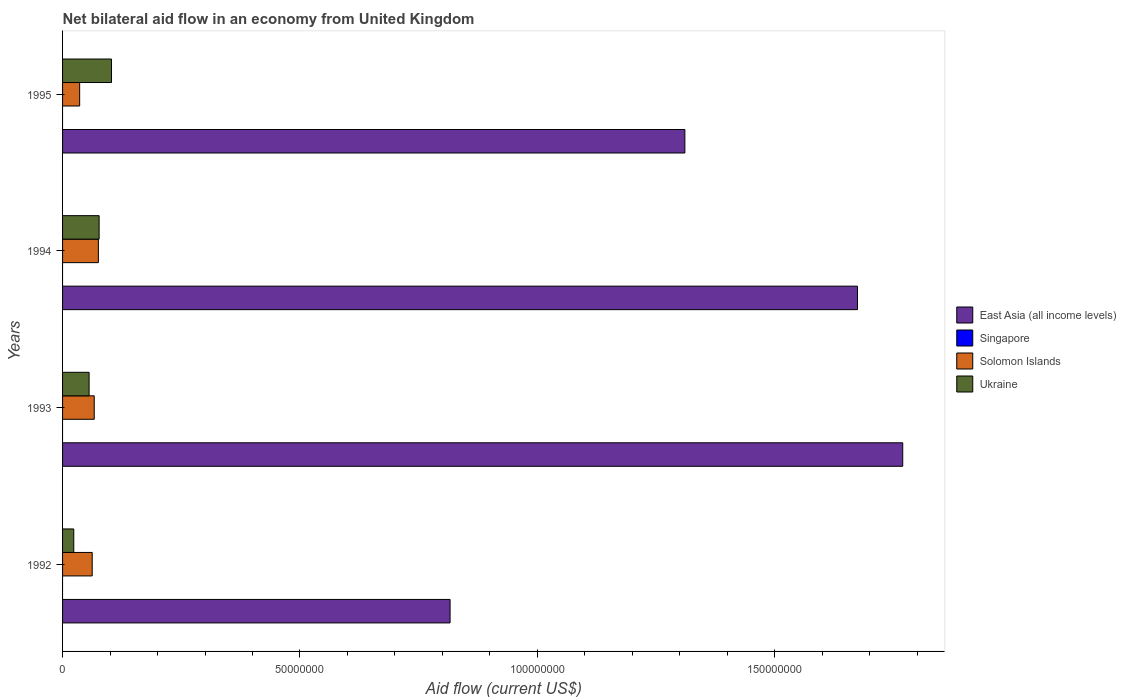How many groups of bars are there?
Your answer should be very brief. 4. Are the number of bars on each tick of the Y-axis equal?
Ensure brevity in your answer.  Yes. How many bars are there on the 2nd tick from the top?
Your answer should be very brief. 3. What is the label of the 1st group of bars from the top?
Your answer should be very brief. 1995. In how many cases, is the number of bars for a given year not equal to the number of legend labels?
Your response must be concise. 4. What is the net bilateral aid flow in Ukraine in 1993?
Offer a terse response. 5.59e+06. Across all years, what is the maximum net bilateral aid flow in East Asia (all income levels)?
Offer a terse response. 1.77e+08. What is the total net bilateral aid flow in Singapore in the graph?
Give a very brief answer. 0. What is the difference between the net bilateral aid flow in Solomon Islands in 1993 and that in 1994?
Ensure brevity in your answer.  -8.70e+05. What is the difference between the net bilateral aid flow in Solomon Islands in 1992 and the net bilateral aid flow in Singapore in 1993?
Your response must be concise. 6.24e+06. What is the average net bilateral aid flow in Ukraine per year?
Make the answer very short. 6.49e+06. In the year 1992, what is the difference between the net bilateral aid flow in Solomon Islands and net bilateral aid flow in Ukraine?
Keep it short and to the point. 3.88e+06. What is the ratio of the net bilateral aid flow in Solomon Islands in 1992 to that in 1993?
Your response must be concise. 0.94. Is the difference between the net bilateral aid flow in Solomon Islands in 1994 and 1995 greater than the difference between the net bilateral aid flow in Ukraine in 1994 and 1995?
Your response must be concise. Yes. What is the difference between the highest and the second highest net bilateral aid flow in East Asia (all income levels)?
Your response must be concise. 9.53e+06. What is the difference between the highest and the lowest net bilateral aid flow in Ukraine?
Provide a succinct answer. 7.95e+06. Is the sum of the net bilateral aid flow in East Asia (all income levels) in 1993 and 1994 greater than the maximum net bilateral aid flow in Singapore across all years?
Keep it short and to the point. Yes. Is it the case that in every year, the sum of the net bilateral aid flow in Ukraine and net bilateral aid flow in Solomon Islands is greater than the net bilateral aid flow in Singapore?
Offer a very short reply. Yes. Are all the bars in the graph horizontal?
Ensure brevity in your answer.  Yes. How many years are there in the graph?
Your response must be concise. 4. Are the values on the major ticks of X-axis written in scientific E-notation?
Offer a terse response. No. Does the graph contain grids?
Your response must be concise. No. How many legend labels are there?
Keep it short and to the point. 4. How are the legend labels stacked?
Provide a succinct answer. Vertical. What is the title of the graph?
Provide a short and direct response. Net bilateral aid flow in an economy from United Kingdom. Does "Ethiopia" appear as one of the legend labels in the graph?
Keep it short and to the point. No. What is the label or title of the Y-axis?
Keep it short and to the point. Years. What is the Aid flow (current US$) in East Asia (all income levels) in 1992?
Your response must be concise. 8.16e+07. What is the Aid flow (current US$) in Singapore in 1992?
Provide a short and direct response. 0. What is the Aid flow (current US$) in Solomon Islands in 1992?
Your answer should be very brief. 6.24e+06. What is the Aid flow (current US$) of Ukraine in 1992?
Make the answer very short. 2.36e+06. What is the Aid flow (current US$) in East Asia (all income levels) in 1993?
Provide a short and direct response. 1.77e+08. What is the Aid flow (current US$) of Singapore in 1993?
Make the answer very short. 0. What is the Aid flow (current US$) in Solomon Islands in 1993?
Your answer should be very brief. 6.67e+06. What is the Aid flow (current US$) of Ukraine in 1993?
Your answer should be compact. 5.59e+06. What is the Aid flow (current US$) in East Asia (all income levels) in 1994?
Your answer should be very brief. 1.67e+08. What is the Aid flow (current US$) of Solomon Islands in 1994?
Give a very brief answer. 7.54e+06. What is the Aid flow (current US$) in Ukraine in 1994?
Provide a short and direct response. 7.70e+06. What is the Aid flow (current US$) of East Asia (all income levels) in 1995?
Make the answer very short. 1.31e+08. What is the Aid flow (current US$) in Solomon Islands in 1995?
Your answer should be very brief. 3.60e+06. What is the Aid flow (current US$) in Ukraine in 1995?
Make the answer very short. 1.03e+07. Across all years, what is the maximum Aid flow (current US$) of East Asia (all income levels)?
Your answer should be very brief. 1.77e+08. Across all years, what is the maximum Aid flow (current US$) of Solomon Islands?
Provide a succinct answer. 7.54e+06. Across all years, what is the maximum Aid flow (current US$) of Ukraine?
Your answer should be very brief. 1.03e+07. Across all years, what is the minimum Aid flow (current US$) of East Asia (all income levels)?
Make the answer very short. 8.16e+07. Across all years, what is the minimum Aid flow (current US$) of Solomon Islands?
Offer a very short reply. 3.60e+06. Across all years, what is the minimum Aid flow (current US$) in Ukraine?
Your answer should be very brief. 2.36e+06. What is the total Aid flow (current US$) in East Asia (all income levels) in the graph?
Offer a terse response. 5.57e+08. What is the total Aid flow (current US$) in Solomon Islands in the graph?
Offer a very short reply. 2.40e+07. What is the total Aid flow (current US$) in Ukraine in the graph?
Keep it short and to the point. 2.60e+07. What is the difference between the Aid flow (current US$) in East Asia (all income levels) in 1992 and that in 1993?
Keep it short and to the point. -9.53e+07. What is the difference between the Aid flow (current US$) of Solomon Islands in 1992 and that in 1993?
Ensure brevity in your answer.  -4.30e+05. What is the difference between the Aid flow (current US$) in Ukraine in 1992 and that in 1993?
Provide a succinct answer. -3.23e+06. What is the difference between the Aid flow (current US$) of East Asia (all income levels) in 1992 and that in 1994?
Provide a succinct answer. -8.58e+07. What is the difference between the Aid flow (current US$) in Solomon Islands in 1992 and that in 1994?
Provide a short and direct response. -1.30e+06. What is the difference between the Aid flow (current US$) in Ukraine in 1992 and that in 1994?
Ensure brevity in your answer.  -5.34e+06. What is the difference between the Aid flow (current US$) of East Asia (all income levels) in 1992 and that in 1995?
Your response must be concise. -4.94e+07. What is the difference between the Aid flow (current US$) in Solomon Islands in 1992 and that in 1995?
Provide a short and direct response. 2.64e+06. What is the difference between the Aid flow (current US$) in Ukraine in 1992 and that in 1995?
Your answer should be compact. -7.95e+06. What is the difference between the Aid flow (current US$) in East Asia (all income levels) in 1993 and that in 1994?
Your response must be concise. 9.53e+06. What is the difference between the Aid flow (current US$) in Solomon Islands in 1993 and that in 1994?
Provide a succinct answer. -8.70e+05. What is the difference between the Aid flow (current US$) of Ukraine in 1993 and that in 1994?
Your answer should be very brief. -2.11e+06. What is the difference between the Aid flow (current US$) of East Asia (all income levels) in 1993 and that in 1995?
Ensure brevity in your answer.  4.59e+07. What is the difference between the Aid flow (current US$) in Solomon Islands in 1993 and that in 1995?
Offer a very short reply. 3.07e+06. What is the difference between the Aid flow (current US$) of Ukraine in 1993 and that in 1995?
Provide a succinct answer. -4.72e+06. What is the difference between the Aid flow (current US$) in East Asia (all income levels) in 1994 and that in 1995?
Offer a terse response. 3.64e+07. What is the difference between the Aid flow (current US$) of Solomon Islands in 1994 and that in 1995?
Give a very brief answer. 3.94e+06. What is the difference between the Aid flow (current US$) in Ukraine in 1994 and that in 1995?
Your answer should be very brief. -2.61e+06. What is the difference between the Aid flow (current US$) of East Asia (all income levels) in 1992 and the Aid flow (current US$) of Solomon Islands in 1993?
Provide a succinct answer. 7.49e+07. What is the difference between the Aid flow (current US$) of East Asia (all income levels) in 1992 and the Aid flow (current US$) of Ukraine in 1993?
Provide a succinct answer. 7.60e+07. What is the difference between the Aid flow (current US$) in Solomon Islands in 1992 and the Aid flow (current US$) in Ukraine in 1993?
Give a very brief answer. 6.50e+05. What is the difference between the Aid flow (current US$) in East Asia (all income levels) in 1992 and the Aid flow (current US$) in Solomon Islands in 1994?
Keep it short and to the point. 7.41e+07. What is the difference between the Aid flow (current US$) of East Asia (all income levels) in 1992 and the Aid flow (current US$) of Ukraine in 1994?
Ensure brevity in your answer.  7.39e+07. What is the difference between the Aid flow (current US$) of Solomon Islands in 1992 and the Aid flow (current US$) of Ukraine in 1994?
Your response must be concise. -1.46e+06. What is the difference between the Aid flow (current US$) of East Asia (all income levels) in 1992 and the Aid flow (current US$) of Solomon Islands in 1995?
Offer a terse response. 7.80e+07. What is the difference between the Aid flow (current US$) in East Asia (all income levels) in 1992 and the Aid flow (current US$) in Ukraine in 1995?
Ensure brevity in your answer.  7.13e+07. What is the difference between the Aid flow (current US$) in Solomon Islands in 1992 and the Aid flow (current US$) in Ukraine in 1995?
Make the answer very short. -4.07e+06. What is the difference between the Aid flow (current US$) of East Asia (all income levels) in 1993 and the Aid flow (current US$) of Solomon Islands in 1994?
Provide a succinct answer. 1.69e+08. What is the difference between the Aid flow (current US$) in East Asia (all income levels) in 1993 and the Aid flow (current US$) in Ukraine in 1994?
Make the answer very short. 1.69e+08. What is the difference between the Aid flow (current US$) in Solomon Islands in 1993 and the Aid flow (current US$) in Ukraine in 1994?
Your answer should be compact. -1.03e+06. What is the difference between the Aid flow (current US$) of East Asia (all income levels) in 1993 and the Aid flow (current US$) of Solomon Islands in 1995?
Your answer should be very brief. 1.73e+08. What is the difference between the Aid flow (current US$) of East Asia (all income levels) in 1993 and the Aid flow (current US$) of Ukraine in 1995?
Give a very brief answer. 1.67e+08. What is the difference between the Aid flow (current US$) of Solomon Islands in 1993 and the Aid flow (current US$) of Ukraine in 1995?
Provide a succinct answer. -3.64e+06. What is the difference between the Aid flow (current US$) in East Asia (all income levels) in 1994 and the Aid flow (current US$) in Solomon Islands in 1995?
Give a very brief answer. 1.64e+08. What is the difference between the Aid flow (current US$) of East Asia (all income levels) in 1994 and the Aid flow (current US$) of Ukraine in 1995?
Keep it short and to the point. 1.57e+08. What is the difference between the Aid flow (current US$) in Solomon Islands in 1994 and the Aid flow (current US$) in Ukraine in 1995?
Your answer should be very brief. -2.77e+06. What is the average Aid flow (current US$) in East Asia (all income levels) per year?
Provide a short and direct response. 1.39e+08. What is the average Aid flow (current US$) of Solomon Islands per year?
Make the answer very short. 6.01e+06. What is the average Aid flow (current US$) in Ukraine per year?
Make the answer very short. 6.49e+06. In the year 1992, what is the difference between the Aid flow (current US$) of East Asia (all income levels) and Aid flow (current US$) of Solomon Islands?
Provide a short and direct response. 7.54e+07. In the year 1992, what is the difference between the Aid flow (current US$) in East Asia (all income levels) and Aid flow (current US$) in Ukraine?
Provide a short and direct response. 7.92e+07. In the year 1992, what is the difference between the Aid flow (current US$) of Solomon Islands and Aid flow (current US$) of Ukraine?
Offer a very short reply. 3.88e+06. In the year 1993, what is the difference between the Aid flow (current US$) in East Asia (all income levels) and Aid flow (current US$) in Solomon Islands?
Your response must be concise. 1.70e+08. In the year 1993, what is the difference between the Aid flow (current US$) of East Asia (all income levels) and Aid flow (current US$) of Ukraine?
Provide a succinct answer. 1.71e+08. In the year 1993, what is the difference between the Aid flow (current US$) of Solomon Islands and Aid flow (current US$) of Ukraine?
Give a very brief answer. 1.08e+06. In the year 1994, what is the difference between the Aid flow (current US$) in East Asia (all income levels) and Aid flow (current US$) in Solomon Islands?
Your answer should be compact. 1.60e+08. In the year 1994, what is the difference between the Aid flow (current US$) in East Asia (all income levels) and Aid flow (current US$) in Ukraine?
Your answer should be very brief. 1.60e+08. In the year 1994, what is the difference between the Aid flow (current US$) of Solomon Islands and Aid flow (current US$) of Ukraine?
Offer a terse response. -1.60e+05. In the year 1995, what is the difference between the Aid flow (current US$) of East Asia (all income levels) and Aid flow (current US$) of Solomon Islands?
Your response must be concise. 1.27e+08. In the year 1995, what is the difference between the Aid flow (current US$) of East Asia (all income levels) and Aid flow (current US$) of Ukraine?
Make the answer very short. 1.21e+08. In the year 1995, what is the difference between the Aid flow (current US$) of Solomon Islands and Aid flow (current US$) of Ukraine?
Make the answer very short. -6.71e+06. What is the ratio of the Aid flow (current US$) of East Asia (all income levels) in 1992 to that in 1993?
Keep it short and to the point. 0.46. What is the ratio of the Aid flow (current US$) of Solomon Islands in 1992 to that in 1993?
Make the answer very short. 0.94. What is the ratio of the Aid flow (current US$) in Ukraine in 1992 to that in 1993?
Ensure brevity in your answer.  0.42. What is the ratio of the Aid flow (current US$) of East Asia (all income levels) in 1992 to that in 1994?
Keep it short and to the point. 0.49. What is the ratio of the Aid flow (current US$) of Solomon Islands in 1992 to that in 1994?
Offer a terse response. 0.83. What is the ratio of the Aid flow (current US$) in Ukraine in 1992 to that in 1994?
Your answer should be very brief. 0.31. What is the ratio of the Aid flow (current US$) of East Asia (all income levels) in 1992 to that in 1995?
Keep it short and to the point. 0.62. What is the ratio of the Aid flow (current US$) in Solomon Islands in 1992 to that in 1995?
Ensure brevity in your answer.  1.73. What is the ratio of the Aid flow (current US$) in Ukraine in 1992 to that in 1995?
Provide a short and direct response. 0.23. What is the ratio of the Aid flow (current US$) in East Asia (all income levels) in 1993 to that in 1994?
Your answer should be compact. 1.06. What is the ratio of the Aid flow (current US$) of Solomon Islands in 1993 to that in 1994?
Offer a very short reply. 0.88. What is the ratio of the Aid flow (current US$) of Ukraine in 1993 to that in 1994?
Ensure brevity in your answer.  0.73. What is the ratio of the Aid flow (current US$) in East Asia (all income levels) in 1993 to that in 1995?
Provide a short and direct response. 1.35. What is the ratio of the Aid flow (current US$) in Solomon Islands in 1993 to that in 1995?
Your answer should be compact. 1.85. What is the ratio of the Aid flow (current US$) of Ukraine in 1993 to that in 1995?
Offer a terse response. 0.54. What is the ratio of the Aid flow (current US$) of East Asia (all income levels) in 1994 to that in 1995?
Your answer should be compact. 1.28. What is the ratio of the Aid flow (current US$) of Solomon Islands in 1994 to that in 1995?
Provide a short and direct response. 2.09. What is the ratio of the Aid flow (current US$) in Ukraine in 1994 to that in 1995?
Ensure brevity in your answer.  0.75. What is the difference between the highest and the second highest Aid flow (current US$) in East Asia (all income levels)?
Provide a short and direct response. 9.53e+06. What is the difference between the highest and the second highest Aid flow (current US$) in Solomon Islands?
Offer a very short reply. 8.70e+05. What is the difference between the highest and the second highest Aid flow (current US$) of Ukraine?
Provide a succinct answer. 2.61e+06. What is the difference between the highest and the lowest Aid flow (current US$) of East Asia (all income levels)?
Offer a very short reply. 9.53e+07. What is the difference between the highest and the lowest Aid flow (current US$) of Solomon Islands?
Your answer should be very brief. 3.94e+06. What is the difference between the highest and the lowest Aid flow (current US$) in Ukraine?
Offer a very short reply. 7.95e+06. 